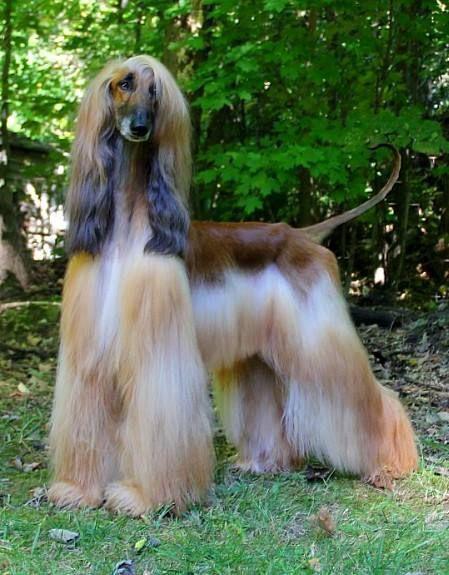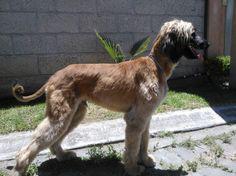The first image is the image on the left, the second image is the image on the right. For the images shown, is this caption "One dog's body is turned to the right, and the other dog's body is turned to the left." true? Answer yes or no. Yes. The first image is the image on the left, the second image is the image on the right. Assess this claim about the two images: "The hound on the left is standing and looking forward with its hair combed over one eye, and the hound on the right is standing with its body in profile.". Correct or not? Answer yes or no. Yes. 